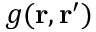<formula> <loc_0><loc_0><loc_500><loc_500>g ( { r } , { r } ^ { \prime } )</formula> 